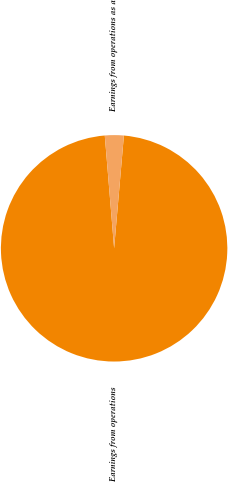Convert chart. <chart><loc_0><loc_0><loc_500><loc_500><pie_chart><fcel>Earnings from operations<fcel>Earnings from operations as a<nl><fcel>97.31%<fcel>2.69%<nl></chart> 